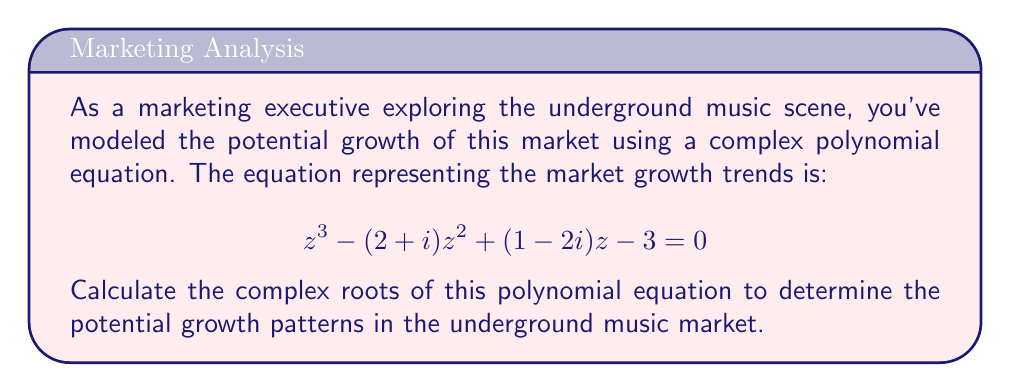Can you answer this question? To solve this cubic equation, we'll use the following steps:

1) First, we'll use the cubic formula to find one root.
2) Then, we'll use polynomial long division to find the other two roots.

Step 1: Using the cubic formula

For a cubic equation $az^3 + bz^2 + cz + d = 0$, we have:

$a = 1$
$b = -(2+i)$
$c = 1-2i$
$d = -3$

Now, let's calculate the following:

$p = \frac{3ac-b^2}{3a^2} = \frac{3(1)(1-2i)-(-2-i)^2}{3(1)^2} = \frac{3-6i-5-2i+i^2}{3} = \frac{-1-8i}{3}$

$q = \frac{2b^3-9abc+27a^2d}{27a^3} = \frac{2(-2-i)^3-9(1)(-2-i)(1-2i)+27(1)^2(-3)}{27(1)^3}$

$= \frac{-8-12i+6i^2-i^3+18+9i-36i-18i^2-81}{27} = \frac{-71-40i+24+i}{27} = \frac{-47-39i}{27}$

Now, we calculate:

$D = (\frac{q}{2})^2 + (\frac{p}{3})^3 = (\frac{-47-39i}{54})^2 + (\frac{-1-8i}{9})^3$

$u = \sqrt[3]{-\frac{q}{2} + \sqrt{D}}$

$v = \sqrt[3]{-\frac{q}{2} - \sqrt{D}}$

The first root is given by:

$z_1 = u + v - \frac{b}{3a}$

Step 2: Polynomial long division

Once we have $z_1$, we can use polynomial long division to find a quadratic equation for the other two roots:

$\frac{z^3 - (2+i)z^2 + (1-2i)z - 3}{z - z_1} = z^2 + pz + q$

The other two roots are then the solutions to:

$z^2 + pz + q = 0$

Which can be solved using the quadratic formula:

$z = \frac{-p \pm \sqrt{p^2-4q}}{2}$
Answer: The three complex roots of the equation $z^3 - (2+i)z^2 + (1-2i)z - 3 = 0$ are:

$z_1 = u + v - \frac{2+i}{3}$

$z_2 = \frac{-p + \sqrt{p^2-4q}}{2}$

$z_3 = \frac{-p - \sqrt{p^2-4q}}{2}$

Where $u$, $v$, $p$, and $q$ are as defined in the explanation. 